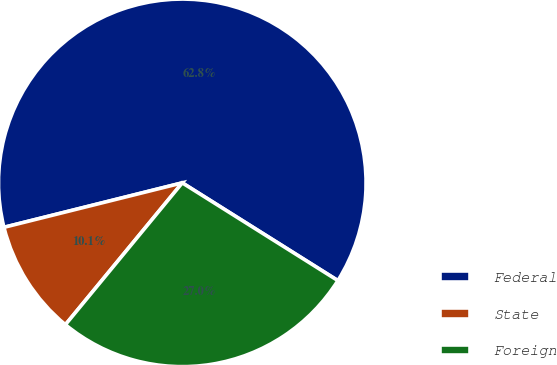<chart> <loc_0><loc_0><loc_500><loc_500><pie_chart><fcel>Federal<fcel>State<fcel>Foreign<nl><fcel>62.81%<fcel>10.14%<fcel>27.04%<nl></chart> 